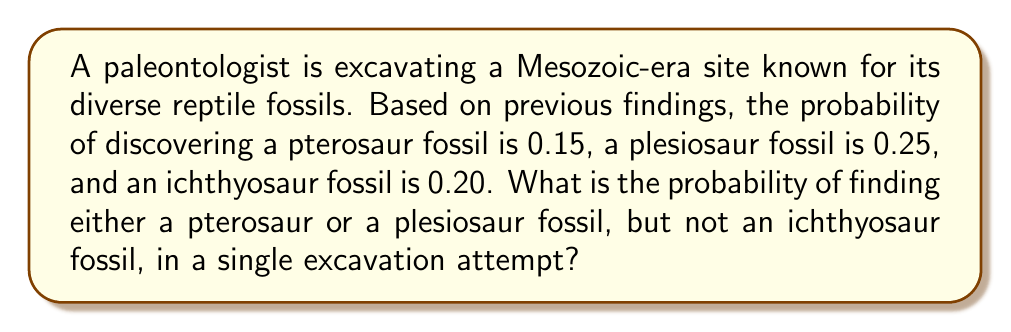Could you help me with this problem? Let's approach this step-by-step using the principles of probability:

1) Let P(A) = probability of finding a pterosaur fossil = 0.15
   Let P(B) = probability of finding a plesiosaur fossil = 0.25
   Let P(C) = probability of finding an ichthyosaur fossil = 0.20

2) We need to find P(A or B) and subtract P(C) from it.

3) To find P(A or B), we use the addition rule of probability:
   P(A or B) = P(A) + P(B) - P(A and B)

4) We don't know P(A and B), but we can assume these events are independent (finding one type of fossil doesn't affect the probability of finding another). So:
   P(A and B) = P(A) × P(B) = 0.15 × 0.25 = 0.0375

5) Now we can calculate P(A or B):
   P(A or B) = 0.15 + 0.25 - 0.0375 = 0.3625

6) The probability we're looking for is P((A or B) and not C). Since C is independent of A and B, we can use:
   P((A or B) and not C) = P(A or B) × (1 - P(C))

7) Substituting the values:
   P((A or B) and not C) = 0.3625 × (1 - 0.20) = 0.3625 × 0.80 = 0.29

Therefore, the probability of finding either a pterosaur or a plesiosaur fossil, but not an ichthyosaur fossil, is 0.29 or 29%.
Answer: 0.29 